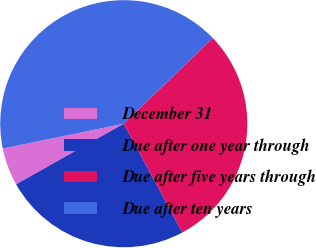Convert chart. <chart><loc_0><loc_0><loc_500><loc_500><pie_chart><fcel>December 31<fcel>Due after one year through<fcel>Due after five years through<fcel>Due after ten years<nl><fcel>4.94%<fcel>24.7%<fcel>29.33%<fcel>41.03%<nl></chart> 